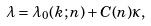Convert formula to latex. <formula><loc_0><loc_0><loc_500><loc_500>\lambda = \lambda _ { 0 } ( k ; n ) + C ( n ) \kappa ,</formula> 